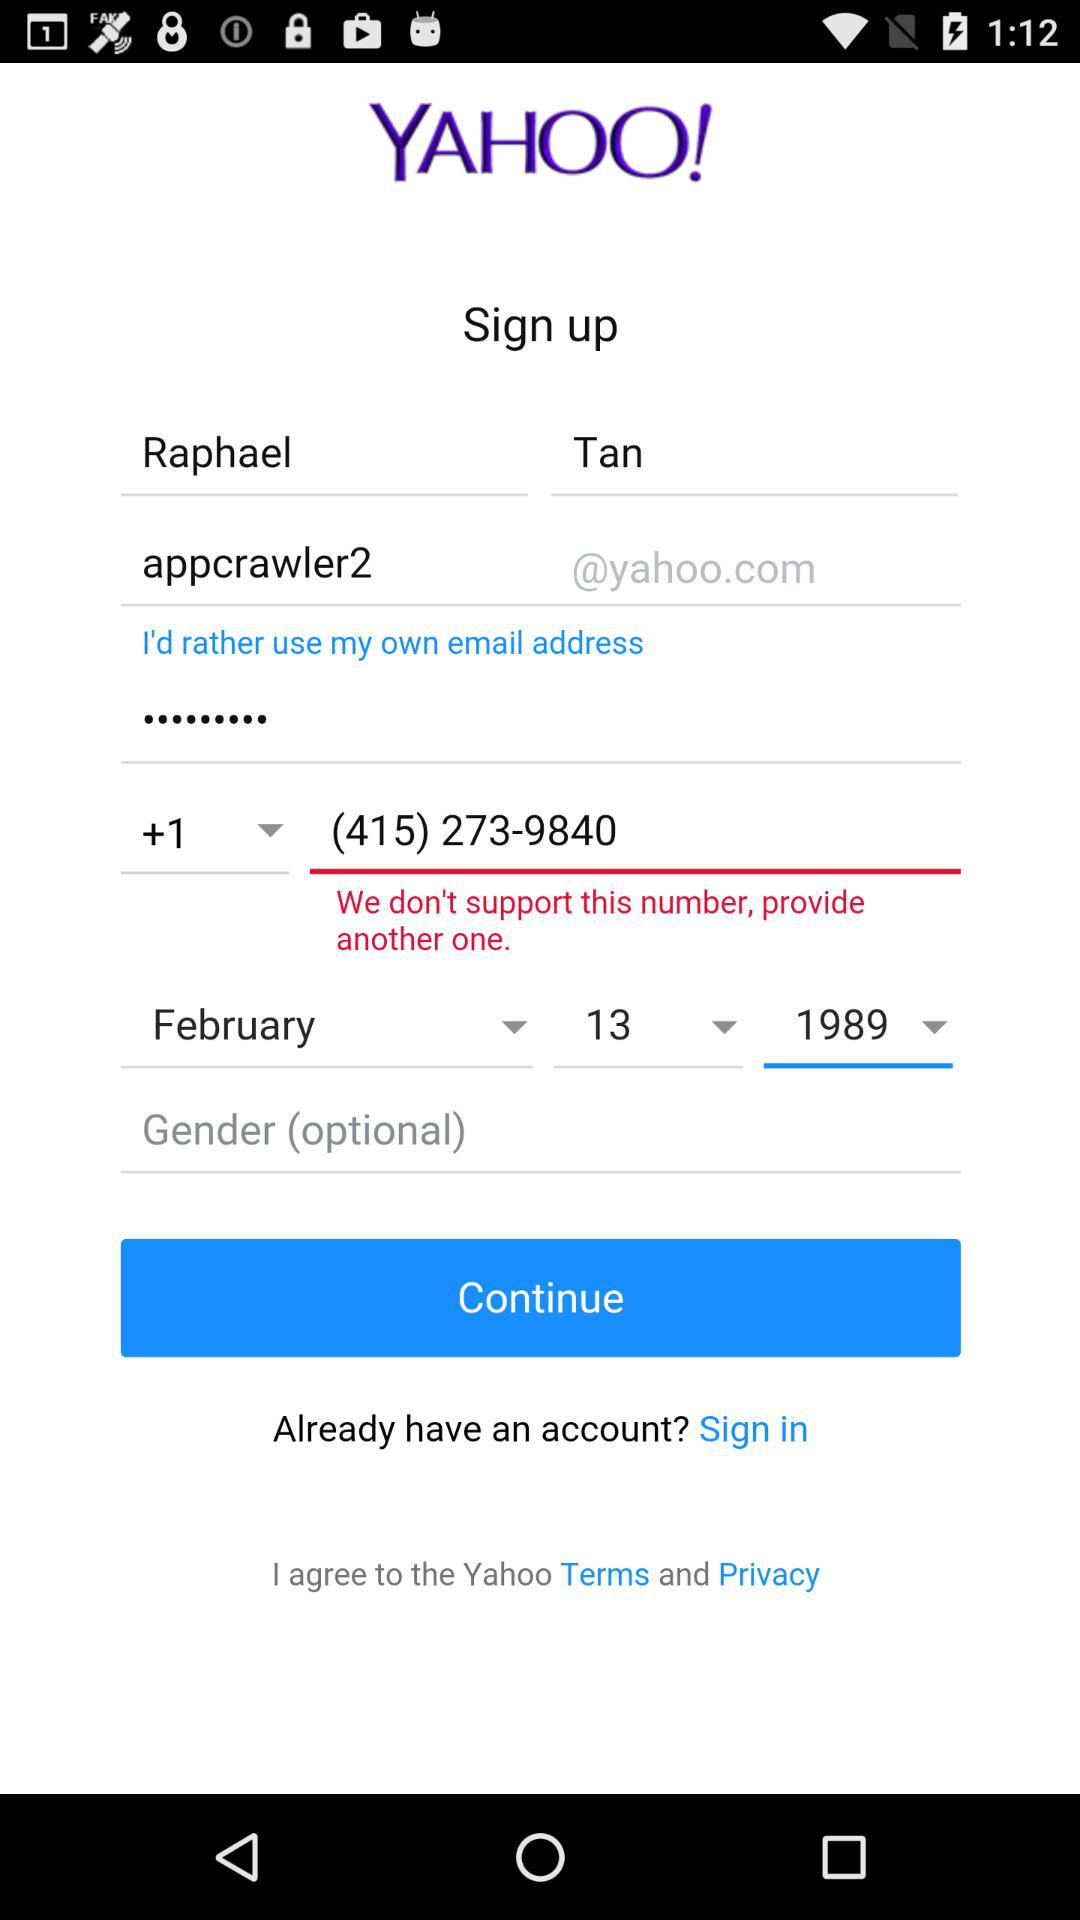What is the name of the application? The name of the application is "YAHOO". 